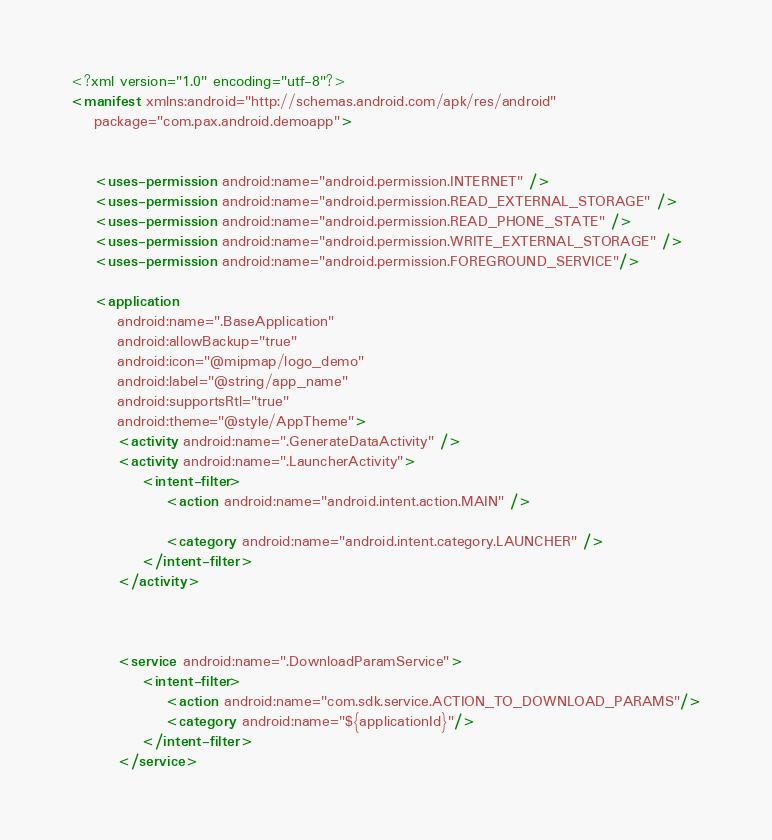<code> <loc_0><loc_0><loc_500><loc_500><_XML_><?xml version="1.0" encoding="utf-8"?>
<manifest xmlns:android="http://schemas.android.com/apk/res/android"
    package="com.pax.android.demoapp">


    <uses-permission android:name="android.permission.INTERNET" />
    <uses-permission android:name="android.permission.READ_EXTERNAL_STORAGE" />
    <uses-permission android:name="android.permission.READ_PHONE_STATE" />
    <uses-permission android:name="android.permission.WRITE_EXTERNAL_STORAGE" />
    <uses-permission android:name="android.permission.FOREGROUND_SERVICE"/>

    <application
        android:name=".BaseApplication"
        android:allowBackup="true"
        android:icon="@mipmap/logo_demo"
        android:label="@string/app_name"
        android:supportsRtl="true"
        android:theme="@style/AppTheme">
        <activity android:name=".GenerateDataActivity" />
        <activity android:name=".LauncherActivity">
            <intent-filter>
                <action android:name="android.intent.action.MAIN" />

                <category android:name="android.intent.category.LAUNCHER" />
            </intent-filter>
        </activity>



        <service android:name=".DownloadParamService">
            <intent-filter>
                <action android:name="com.sdk.service.ACTION_TO_DOWNLOAD_PARAMS"/>
                <category android:name="${applicationId}"/>
            </intent-filter>
        </service>
</code> 